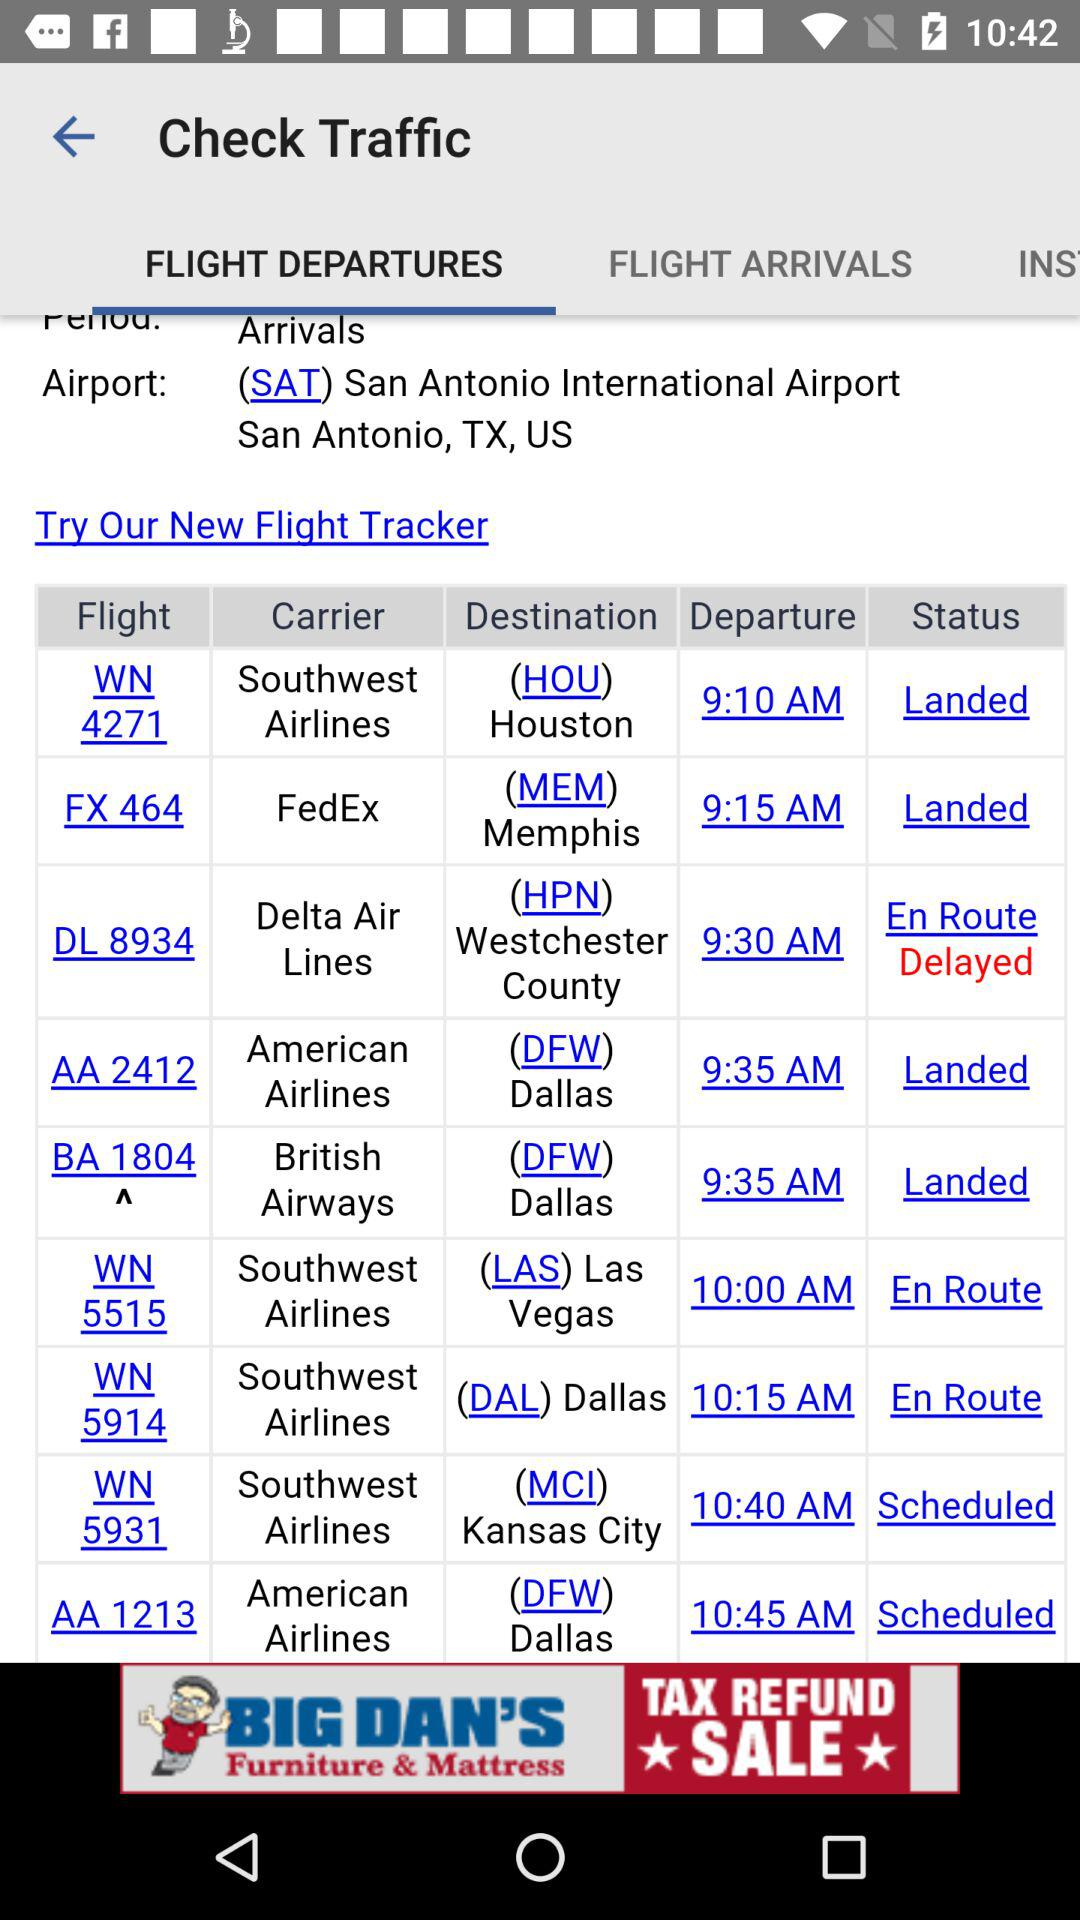Which tab is currently selected under "Check Traffic"? The currently selected tab is "FLIGHT DEPARTURES". 